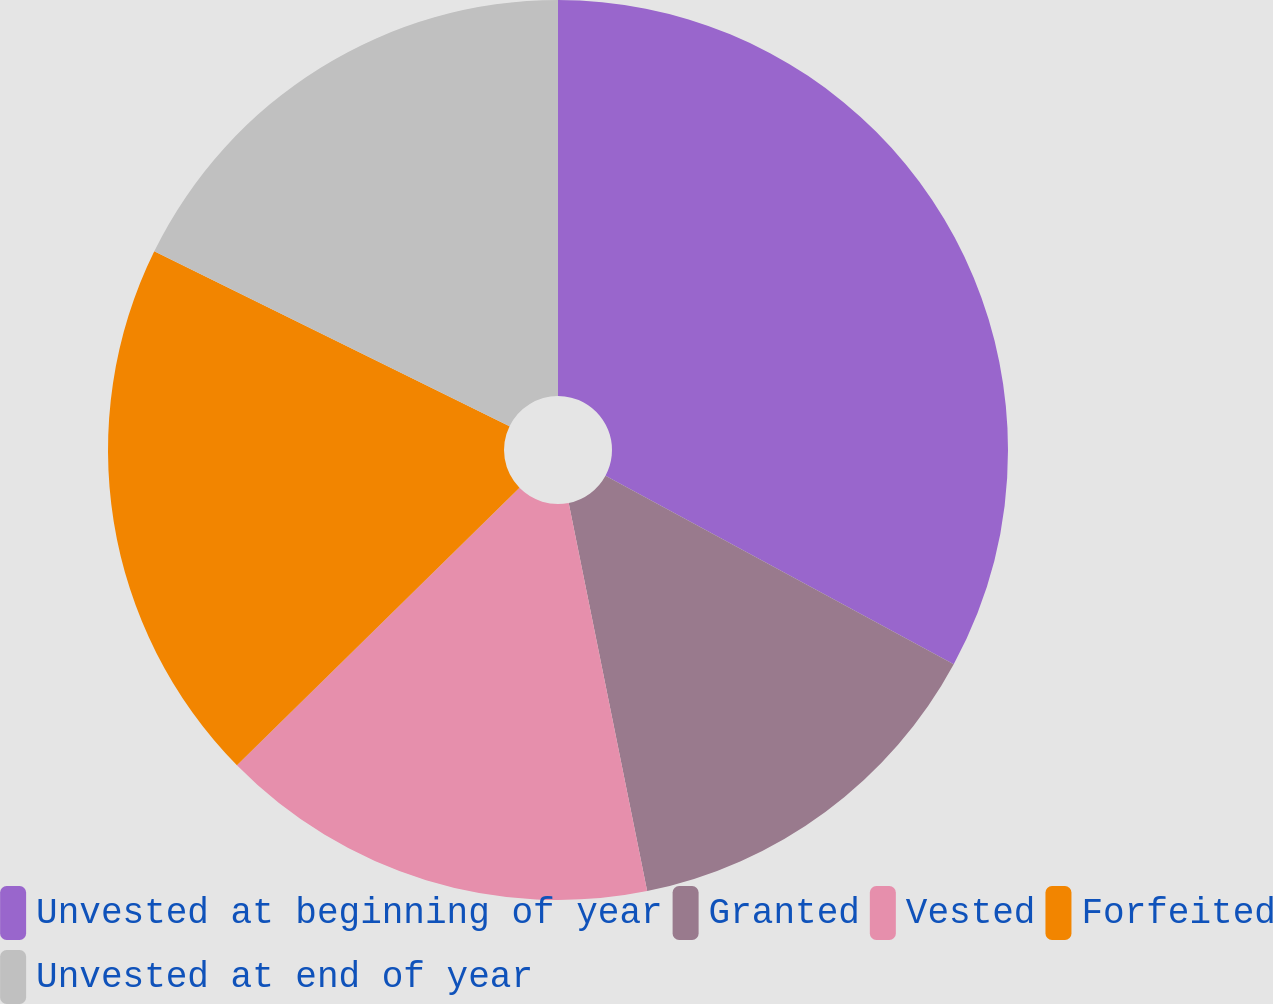Convert chart. <chart><loc_0><loc_0><loc_500><loc_500><pie_chart><fcel>Unvested at beginning of year<fcel>Granted<fcel>Vested<fcel>Forfeited<fcel>Unvested at end of year<nl><fcel>32.9%<fcel>13.93%<fcel>15.82%<fcel>19.64%<fcel>17.72%<nl></chart> 